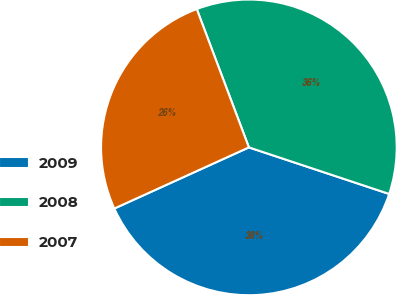Convert chart. <chart><loc_0><loc_0><loc_500><loc_500><pie_chart><fcel>2009<fcel>2008<fcel>2007<nl><fcel>38.11%<fcel>35.84%<fcel>26.05%<nl></chart> 